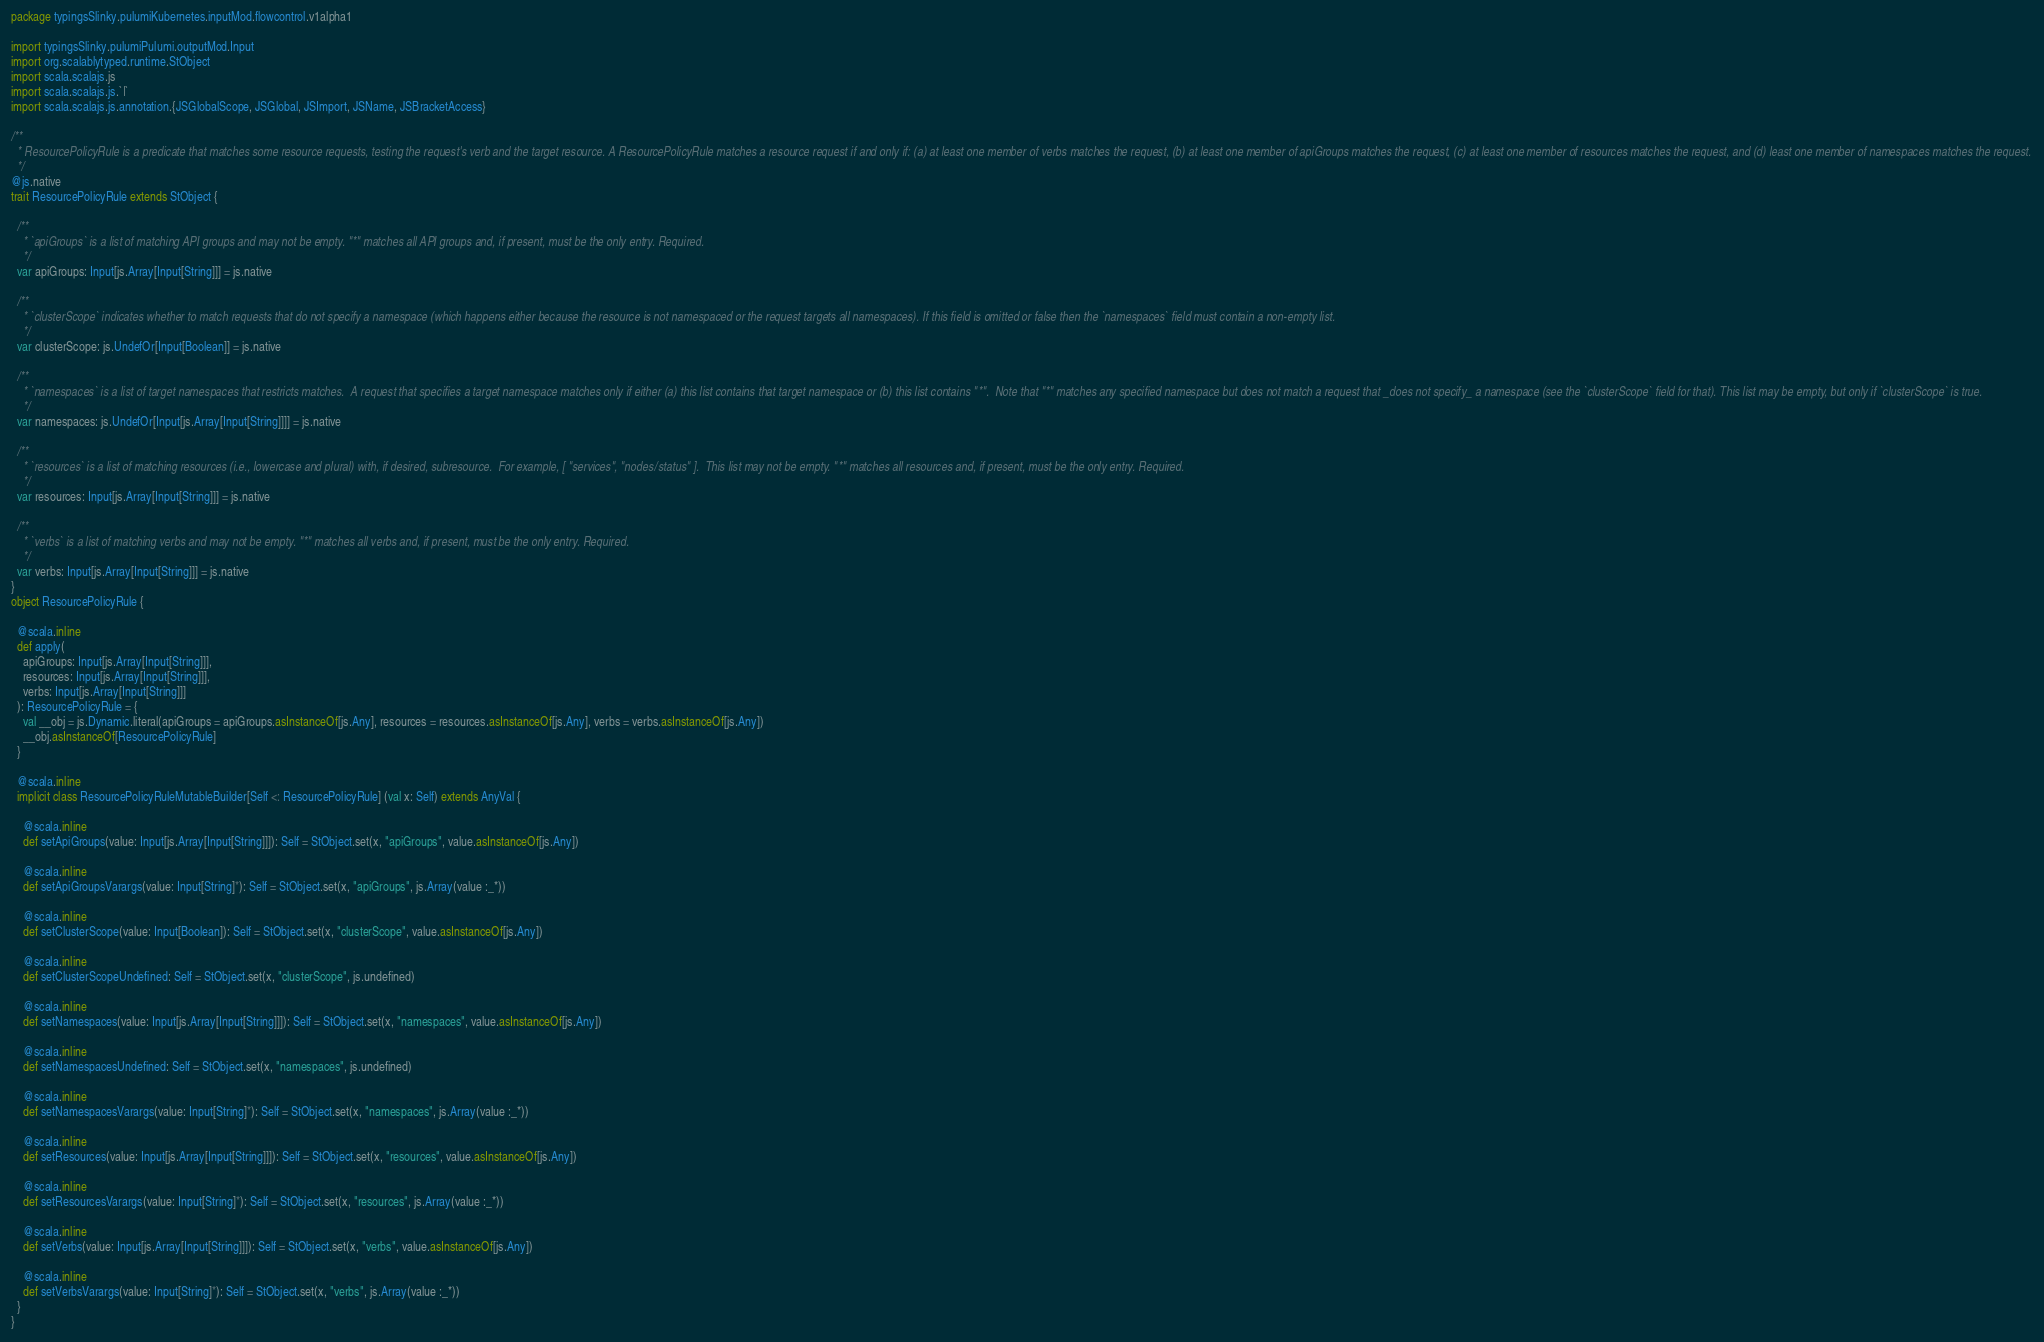Convert code to text. <code><loc_0><loc_0><loc_500><loc_500><_Scala_>package typingsSlinky.pulumiKubernetes.inputMod.flowcontrol.v1alpha1

import typingsSlinky.pulumiPulumi.outputMod.Input
import org.scalablytyped.runtime.StObject
import scala.scalajs.js
import scala.scalajs.js.`|`
import scala.scalajs.js.annotation.{JSGlobalScope, JSGlobal, JSImport, JSName, JSBracketAccess}

/**
  * ResourcePolicyRule is a predicate that matches some resource requests, testing the request's verb and the target resource. A ResourcePolicyRule matches a resource request if and only if: (a) at least one member of verbs matches the request, (b) at least one member of apiGroups matches the request, (c) at least one member of resources matches the request, and (d) least one member of namespaces matches the request.
  */
@js.native
trait ResourcePolicyRule extends StObject {
  
  /**
    * `apiGroups` is a list of matching API groups and may not be empty. "*" matches all API groups and, if present, must be the only entry. Required.
    */
  var apiGroups: Input[js.Array[Input[String]]] = js.native
  
  /**
    * `clusterScope` indicates whether to match requests that do not specify a namespace (which happens either because the resource is not namespaced or the request targets all namespaces). If this field is omitted or false then the `namespaces` field must contain a non-empty list.
    */
  var clusterScope: js.UndefOr[Input[Boolean]] = js.native
  
  /**
    * `namespaces` is a list of target namespaces that restricts matches.  A request that specifies a target namespace matches only if either (a) this list contains that target namespace or (b) this list contains "*".  Note that "*" matches any specified namespace but does not match a request that _does not specify_ a namespace (see the `clusterScope` field for that). This list may be empty, but only if `clusterScope` is true.
    */
  var namespaces: js.UndefOr[Input[js.Array[Input[String]]]] = js.native
  
  /**
    * `resources` is a list of matching resources (i.e., lowercase and plural) with, if desired, subresource.  For example, [ "services", "nodes/status" ].  This list may not be empty. "*" matches all resources and, if present, must be the only entry. Required.
    */
  var resources: Input[js.Array[Input[String]]] = js.native
  
  /**
    * `verbs` is a list of matching verbs and may not be empty. "*" matches all verbs and, if present, must be the only entry. Required.
    */
  var verbs: Input[js.Array[Input[String]]] = js.native
}
object ResourcePolicyRule {
  
  @scala.inline
  def apply(
    apiGroups: Input[js.Array[Input[String]]],
    resources: Input[js.Array[Input[String]]],
    verbs: Input[js.Array[Input[String]]]
  ): ResourcePolicyRule = {
    val __obj = js.Dynamic.literal(apiGroups = apiGroups.asInstanceOf[js.Any], resources = resources.asInstanceOf[js.Any], verbs = verbs.asInstanceOf[js.Any])
    __obj.asInstanceOf[ResourcePolicyRule]
  }
  
  @scala.inline
  implicit class ResourcePolicyRuleMutableBuilder[Self <: ResourcePolicyRule] (val x: Self) extends AnyVal {
    
    @scala.inline
    def setApiGroups(value: Input[js.Array[Input[String]]]): Self = StObject.set(x, "apiGroups", value.asInstanceOf[js.Any])
    
    @scala.inline
    def setApiGroupsVarargs(value: Input[String]*): Self = StObject.set(x, "apiGroups", js.Array(value :_*))
    
    @scala.inline
    def setClusterScope(value: Input[Boolean]): Self = StObject.set(x, "clusterScope", value.asInstanceOf[js.Any])
    
    @scala.inline
    def setClusterScopeUndefined: Self = StObject.set(x, "clusterScope", js.undefined)
    
    @scala.inline
    def setNamespaces(value: Input[js.Array[Input[String]]]): Self = StObject.set(x, "namespaces", value.asInstanceOf[js.Any])
    
    @scala.inline
    def setNamespacesUndefined: Self = StObject.set(x, "namespaces", js.undefined)
    
    @scala.inline
    def setNamespacesVarargs(value: Input[String]*): Self = StObject.set(x, "namespaces", js.Array(value :_*))
    
    @scala.inline
    def setResources(value: Input[js.Array[Input[String]]]): Self = StObject.set(x, "resources", value.asInstanceOf[js.Any])
    
    @scala.inline
    def setResourcesVarargs(value: Input[String]*): Self = StObject.set(x, "resources", js.Array(value :_*))
    
    @scala.inline
    def setVerbs(value: Input[js.Array[Input[String]]]): Self = StObject.set(x, "verbs", value.asInstanceOf[js.Any])
    
    @scala.inline
    def setVerbsVarargs(value: Input[String]*): Self = StObject.set(x, "verbs", js.Array(value :_*))
  }
}
</code> 